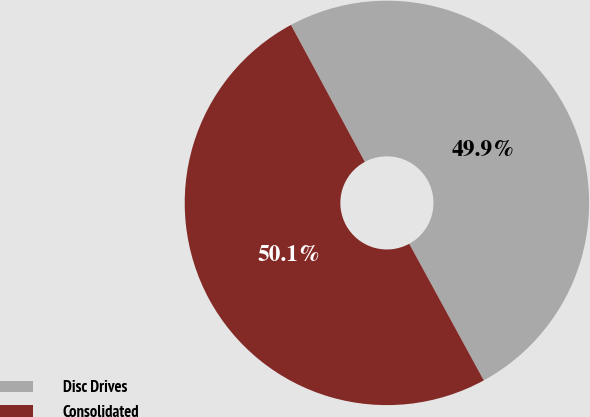<chart> <loc_0><loc_0><loc_500><loc_500><pie_chart><fcel>Disc Drives<fcel>Consolidated<nl><fcel>49.92%<fcel>50.08%<nl></chart> 